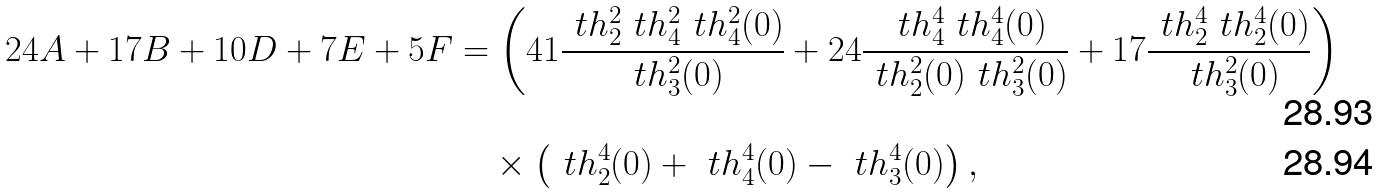<formula> <loc_0><loc_0><loc_500><loc_500>2 4 A + 1 7 B + 1 0 D + 7 E + 5 F & = \left ( 4 1 \frac { \ t h _ { 2 } ^ { 2 } \ t h _ { 4 } ^ { 2 } \ t h _ { 4 } ^ { 2 } ( 0 ) } { \ t h _ { 3 } ^ { 2 } ( 0 ) } + 2 4 \frac { \ t h _ { 4 } ^ { 4 } \ t h _ { 4 } ^ { 4 } ( 0 ) } { \ t h _ { 2 } ^ { 2 } ( 0 ) \ t h _ { 3 } ^ { 2 } ( 0 ) } + 1 7 \frac { \ t h _ { 2 } ^ { 4 } \ t h _ { 2 } ^ { 4 } ( 0 ) } { \ t h _ { 3 } ^ { 2 } ( 0 ) } \right ) \\ & \quad \times \left ( \ t h _ { 2 } ^ { 4 } ( 0 ) + \ t h _ { 4 } ^ { 4 } ( 0 ) - \ t h _ { 3 } ^ { 4 } ( 0 ) \right ) ,</formula> 